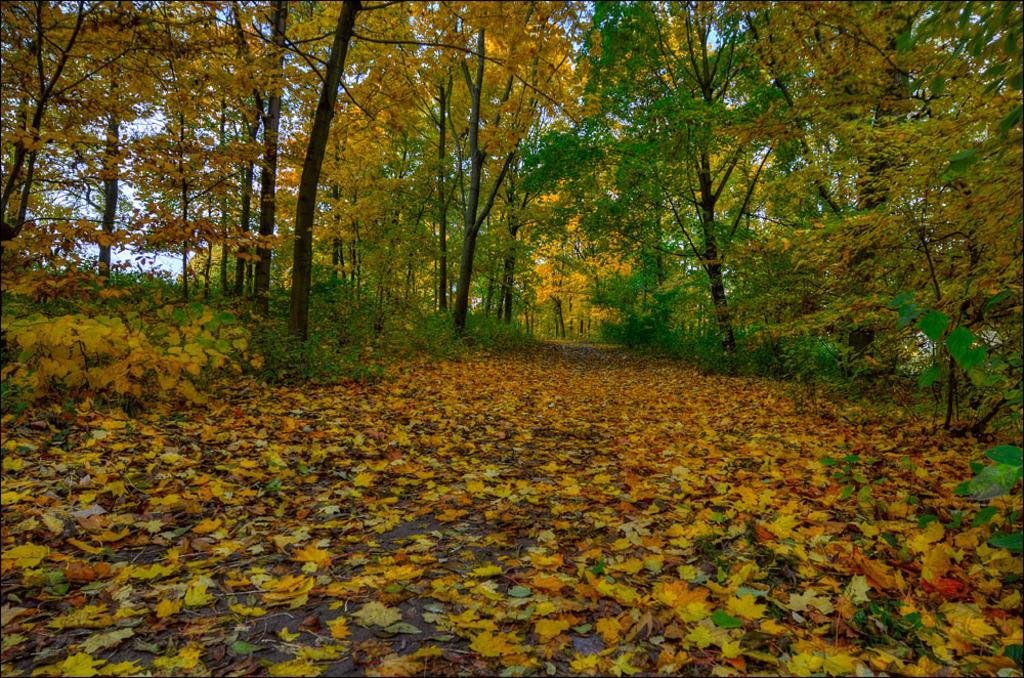Can you describe this image briefly? At bottom of the image I can see many leaves on the ground. In the background there are trees. 